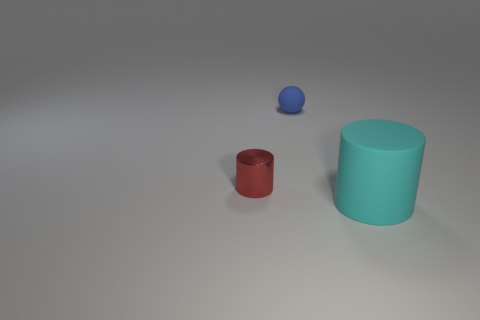Is the number of big cyan cylinders on the right side of the large cyan cylinder less than the number of tiny blue things?
Your answer should be compact. Yes. Are there any other red shiny things that have the same shape as the red metal object?
Give a very brief answer. No. There is a blue thing that is the same size as the red shiny object; what is its shape?
Your response must be concise. Sphere. How many things are large cyan cylinders or blue things?
Make the answer very short. 2. Are there any large red objects?
Provide a succinct answer. No. Is the number of small yellow rubber objects less than the number of rubber balls?
Your answer should be compact. Yes. Are there any blue objects of the same size as the red metal cylinder?
Ensure brevity in your answer.  Yes. Does the big thing have the same shape as the small object in front of the blue matte ball?
Your answer should be very brief. Yes. How many balls are either red objects or large things?
Offer a very short reply. 0. What color is the tiny cylinder?
Keep it short and to the point. Red. 